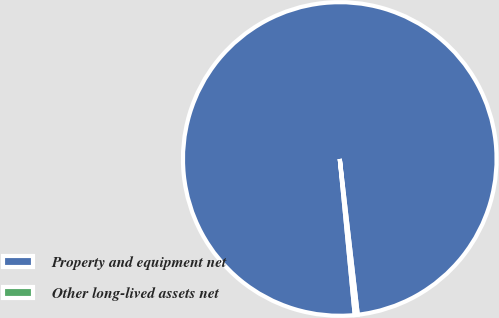Convert chart. <chart><loc_0><loc_0><loc_500><loc_500><pie_chart><fcel>Property and equipment net<fcel>Other long-lived assets net<nl><fcel>99.69%<fcel>0.31%<nl></chart> 